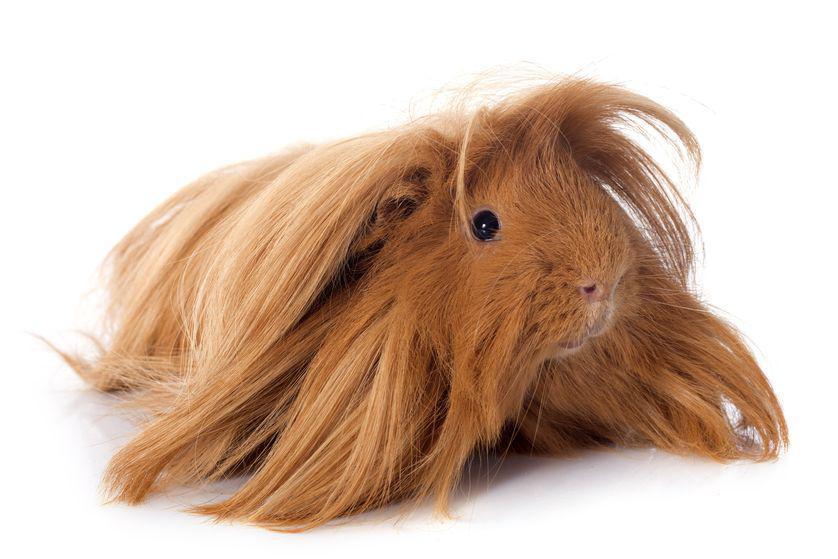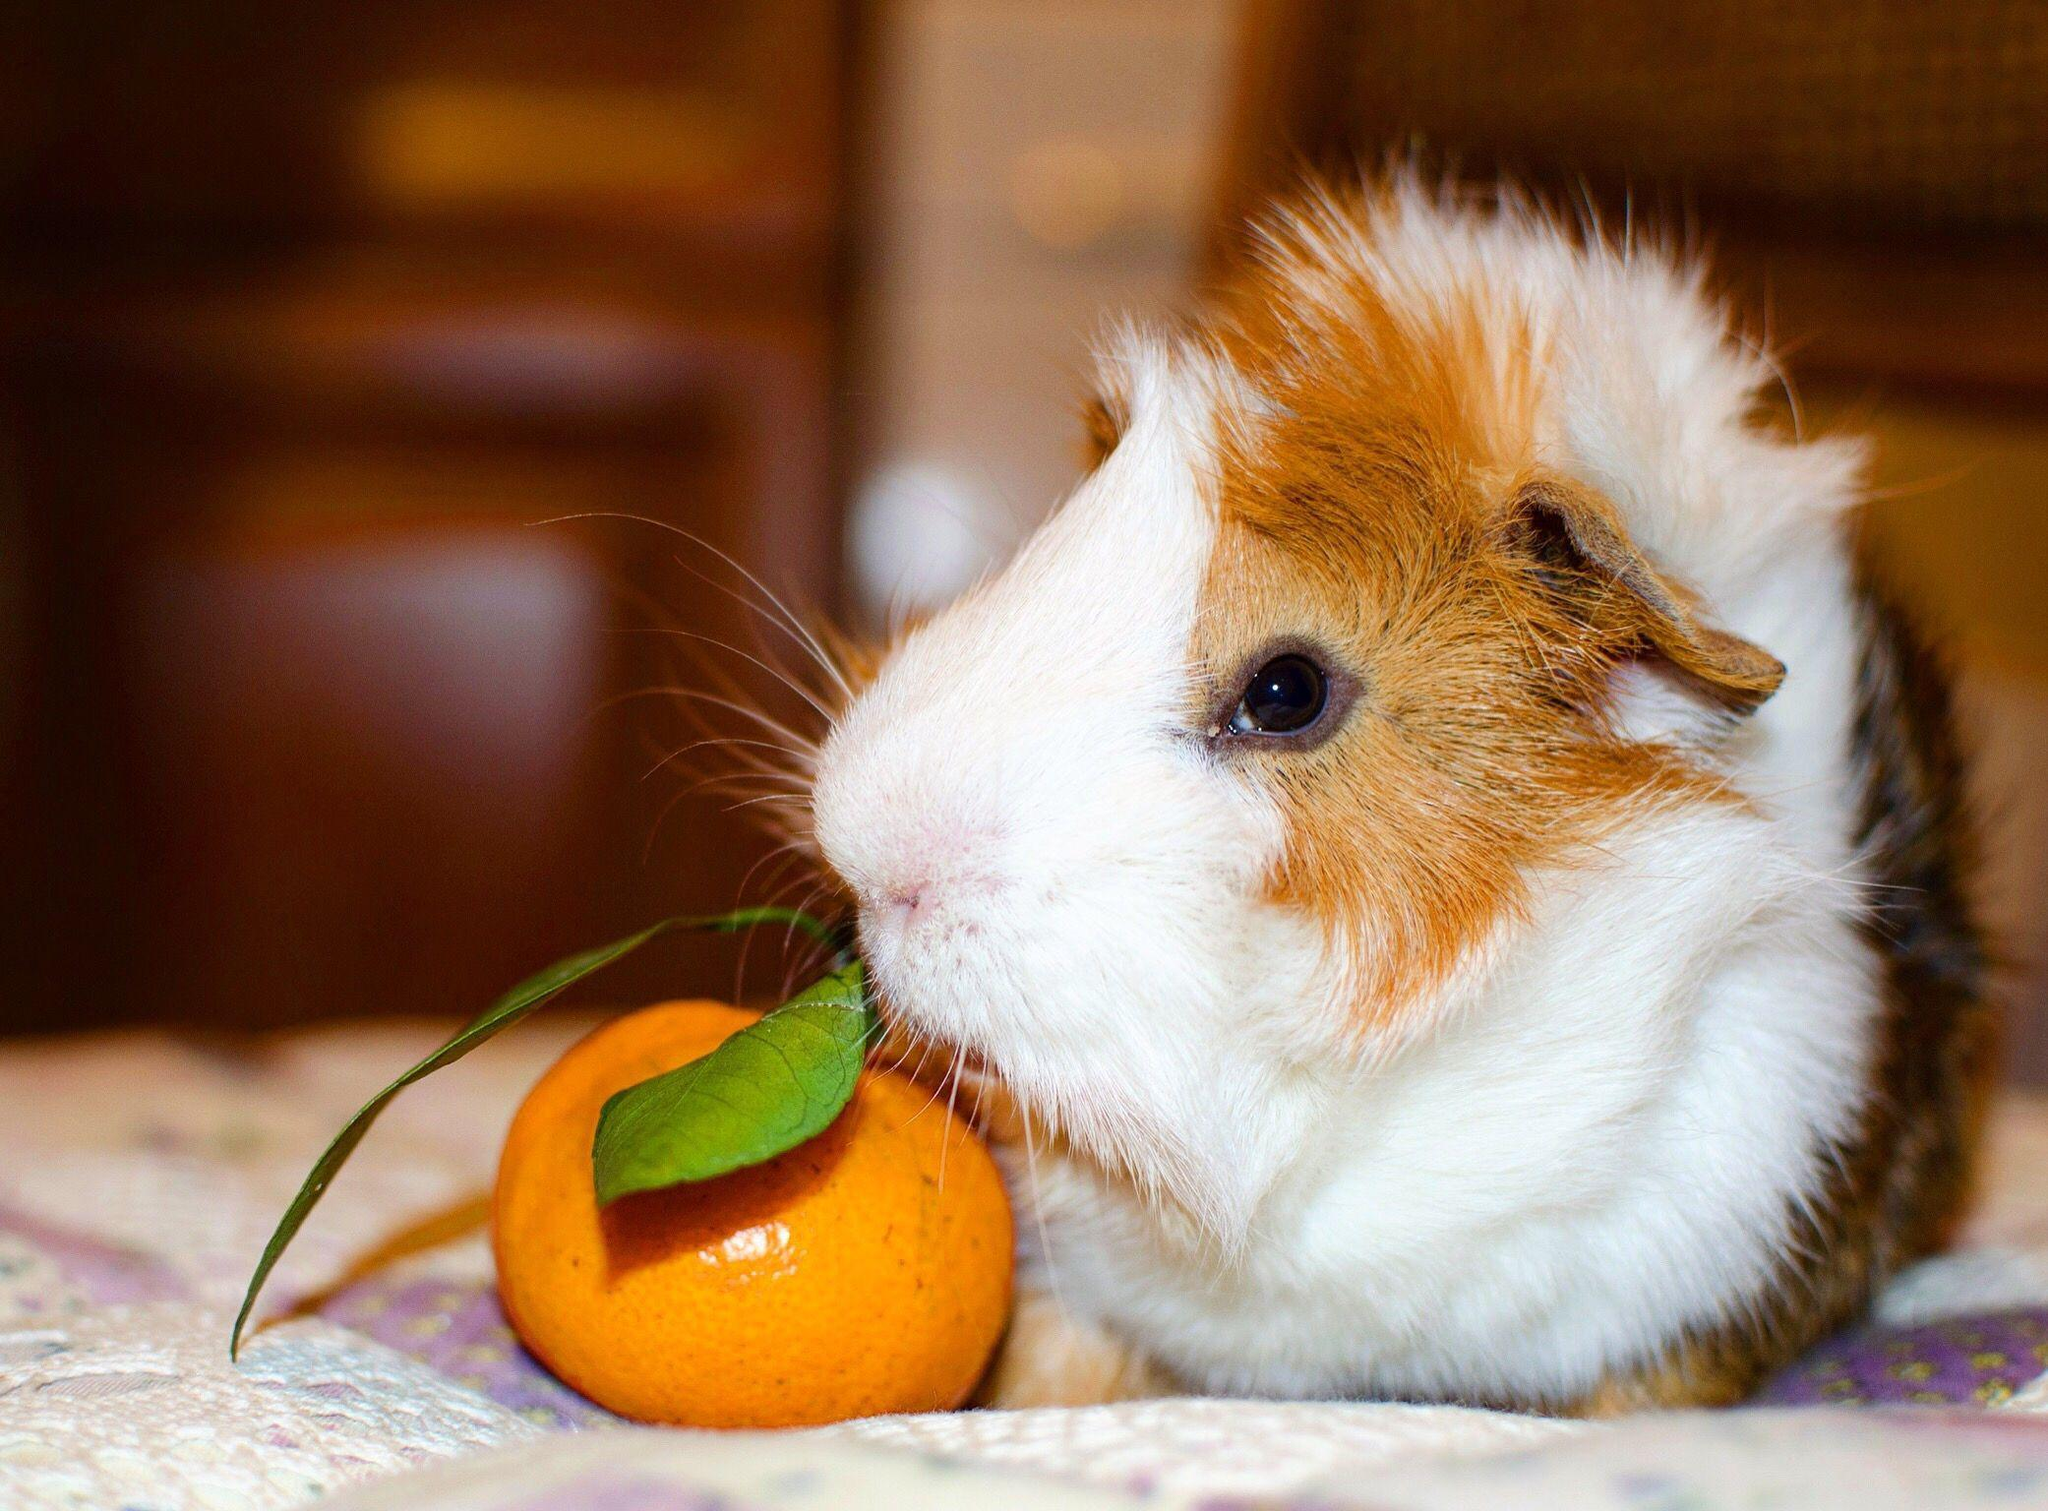The first image is the image on the left, the second image is the image on the right. Examine the images to the left and right. Is the description "There are three guinea pigs" accurate? Answer yes or no. No. 